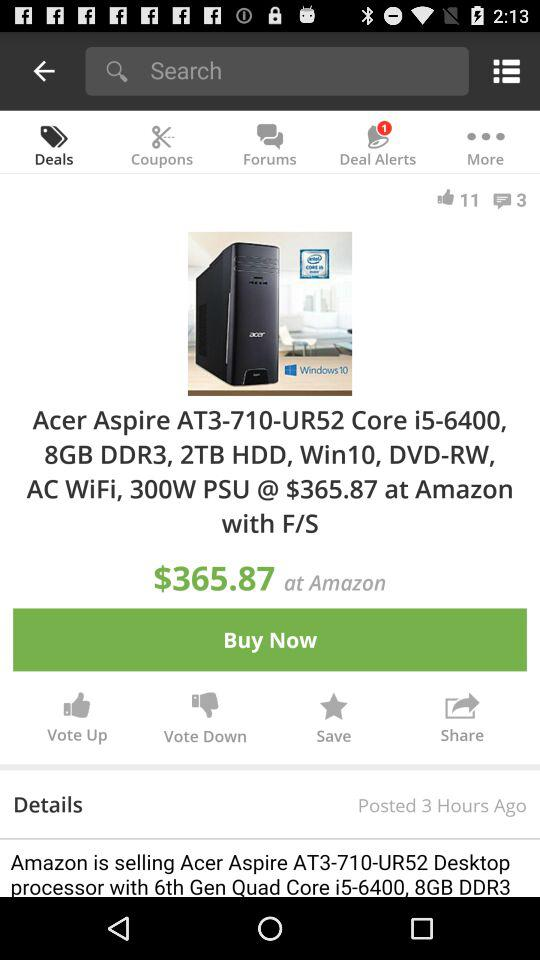What is the price of the product?
Answer the question using a single word or phrase. $365.87 